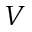Convert formula to latex. <formula><loc_0><loc_0><loc_500><loc_500>V</formula> 